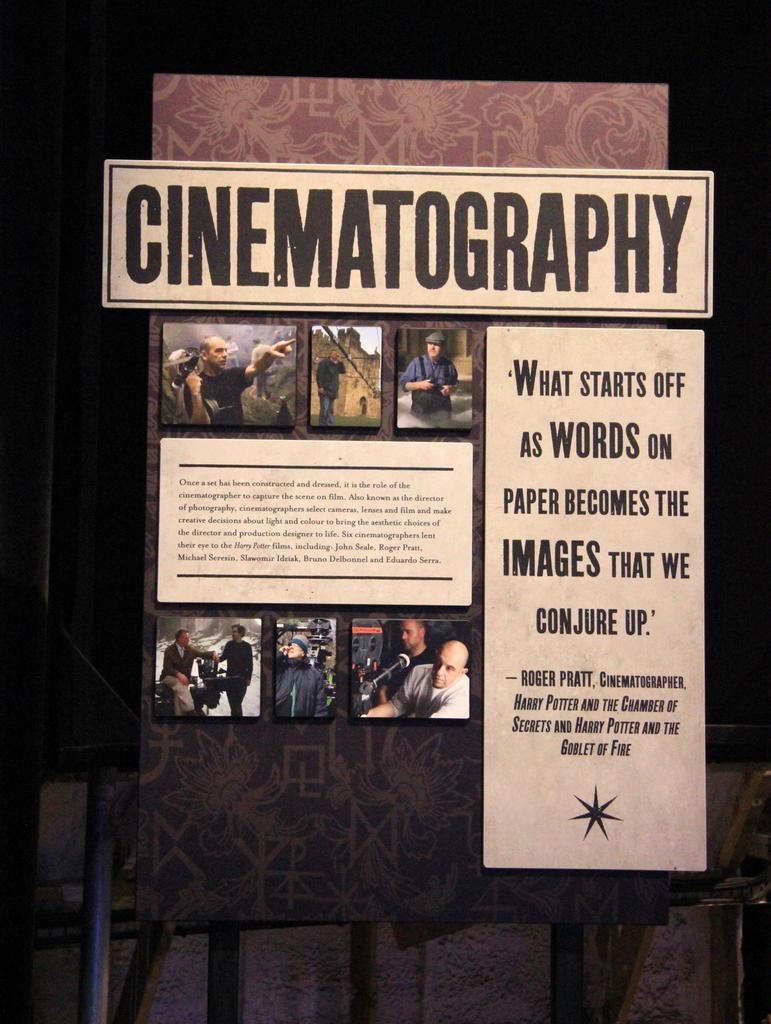<image>
Give a short and clear explanation of the subsequent image. A sign about Cinematography with a quote from Roger Pratt. 